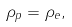Convert formula to latex. <formula><loc_0><loc_0><loc_500><loc_500>\rho _ { p } = \rho _ { e } ,</formula> 